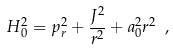<formula> <loc_0><loc_0><loc_500><loc_500>H _ { 0 } ^ { 2 } = p _ { r } ^ { 2 } + { \frac { J ^ { 2 } } { r ^ { 2 } } } + a _ { 0 } ^ { 2 } r ^ { 2 } \ ,</formula> 